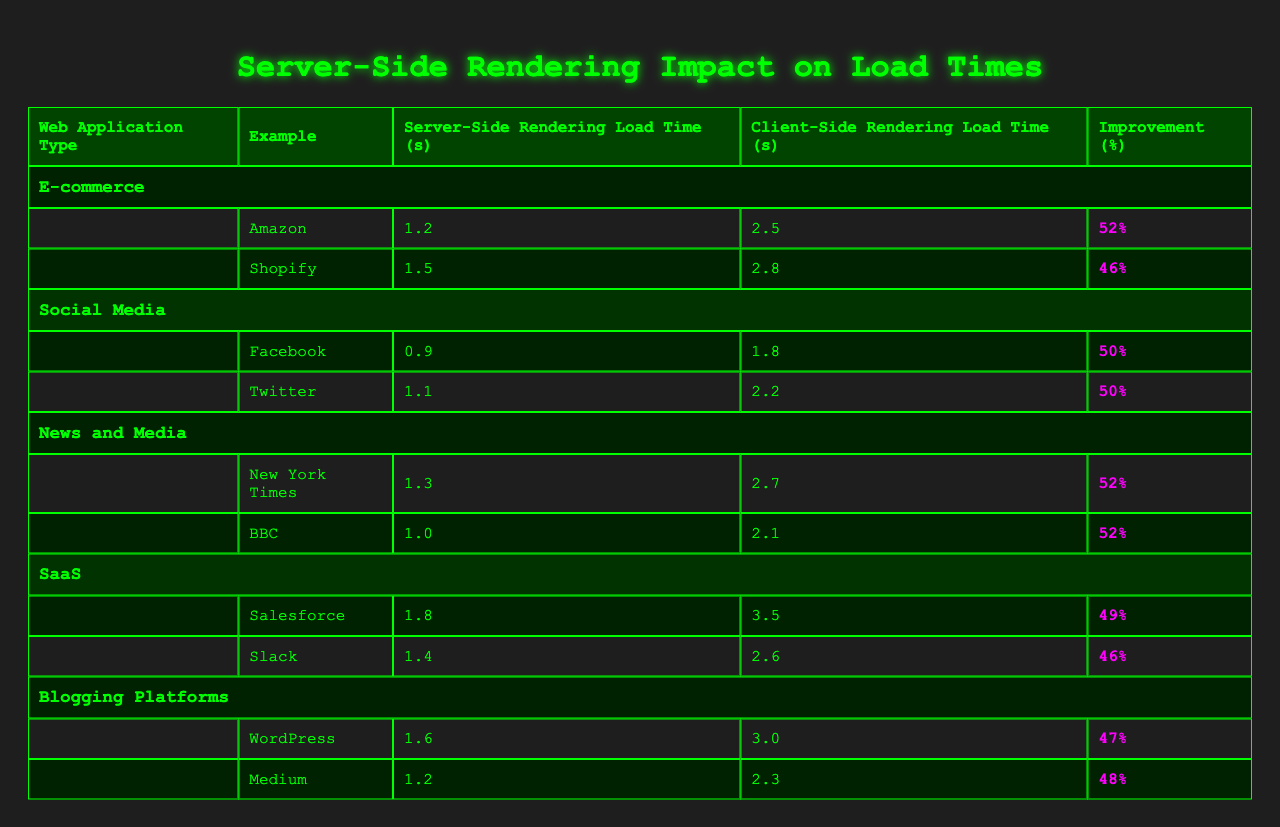What is the server-side rendering load time for Amazon? The table shows the server-side rendering load time for Amazon listed under the E-commerce category as 1.2 seconds.
Answer: 1.2 seconds What is the improvement percentage for Wordpress? The table lists the improvement percentage for Wordpress under Blogging Platforms as 47%.
Answer: 47% Which web application type has the highest server-side rendering load time? Comparing all server-side rendering load times in the table, Salesforce has the highest at 1.8 seconds in the SaaS category.
Answer: SaaS What is the average server-side rendering load time across all applications? The server-side rendering load times are: 1.2, 1.5, 0.9, 1.1, 1.3, 1.0, 1.8, 1.4, 1.6, 1.2. Summing them gives 12.0, and dividing by 10 (the number of applications) results in an average of 1.2 seconds.
Answer: 1.2 seconds For social media applications, what is the difference between server-side rendering load time and client-side rendering load time for Twitter? The server-side rendering load time for Twitter is 1.1 seconds and client-side rendering load time is 2.2 seconds. The difference is 2.2 - 1.1 = 1.1 seconds.
Answer: 1.1 seconds Which application type shows the highest improvement percentage? Checking the improvement percentages, both New York Times and BBC among News and Media and Facebook and Twitter among Social Media show the highest percentage of 52%.
Answer: News and Media & Social Media Is the server-side rendering load time for Shopify less than 2 seconds? According to the table, the server-side rendering load time for Shopify is 1.5 seconds, which is indeed less than 2 seconds.
Answer: Yes What are the server-side rendering load times for the two examples under Blogging Platforms? The table states that for Blogging Platforms, the server-side rendering load times are 1.6 seconds for Wordpress and 1.2 seconds for Medium.
Answer: 1.6 seconds (WordPress), 1.2 seconds (Medium) What is the total improvement percentage across all applications combined? To find the total improvement percentage across all applications, you would sum each individual percentage (52 + 46 + 50 + 50 + 52 + 52 + 49 + 46 + 47 + 48 =  479) and then divide by the number of applications (10), resulting in an average of approximately 47.9%.
Answer: 47.9% What is the client-side rendering load time for BBC? Referring to the table, the client-side rendering load time for BBC is 2.1 seconds.
Answer: 2.1 seconds 